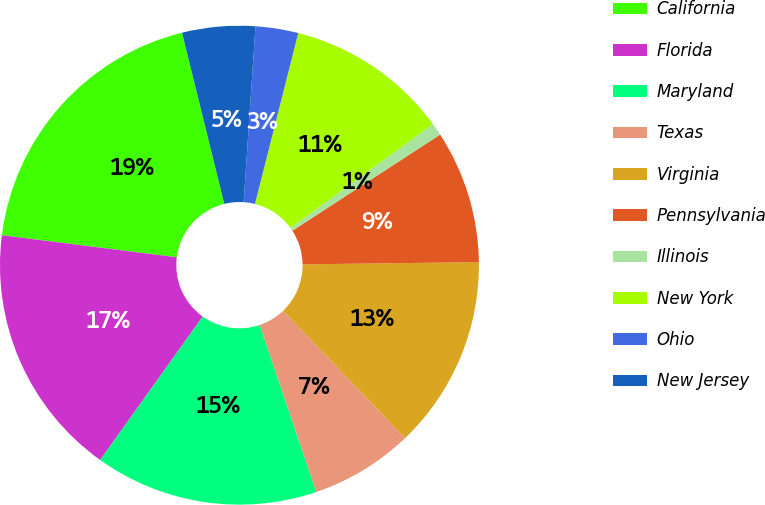Convert chart to OTSL. <chart><loc_0><loc_0><loc_500><loc_500><pie_chart><fcel>California<fcel>Florida<fcel>Maryland<fcel>Texas<fcel>Virginia<fcel>Pennsylvania<fcel>Illinois<fcel>New York<fcel>Ohio<fcel>New Jersey<nl><fcel>19.15%<fcel>17.12%<fcel>15.08%<fcel>6.95%<fcel>13.05%<fcel>8.98%<fcel>0.85%<fcel>11.02%<fcel>2.88%<fcel>4.92%<nl></chart> 